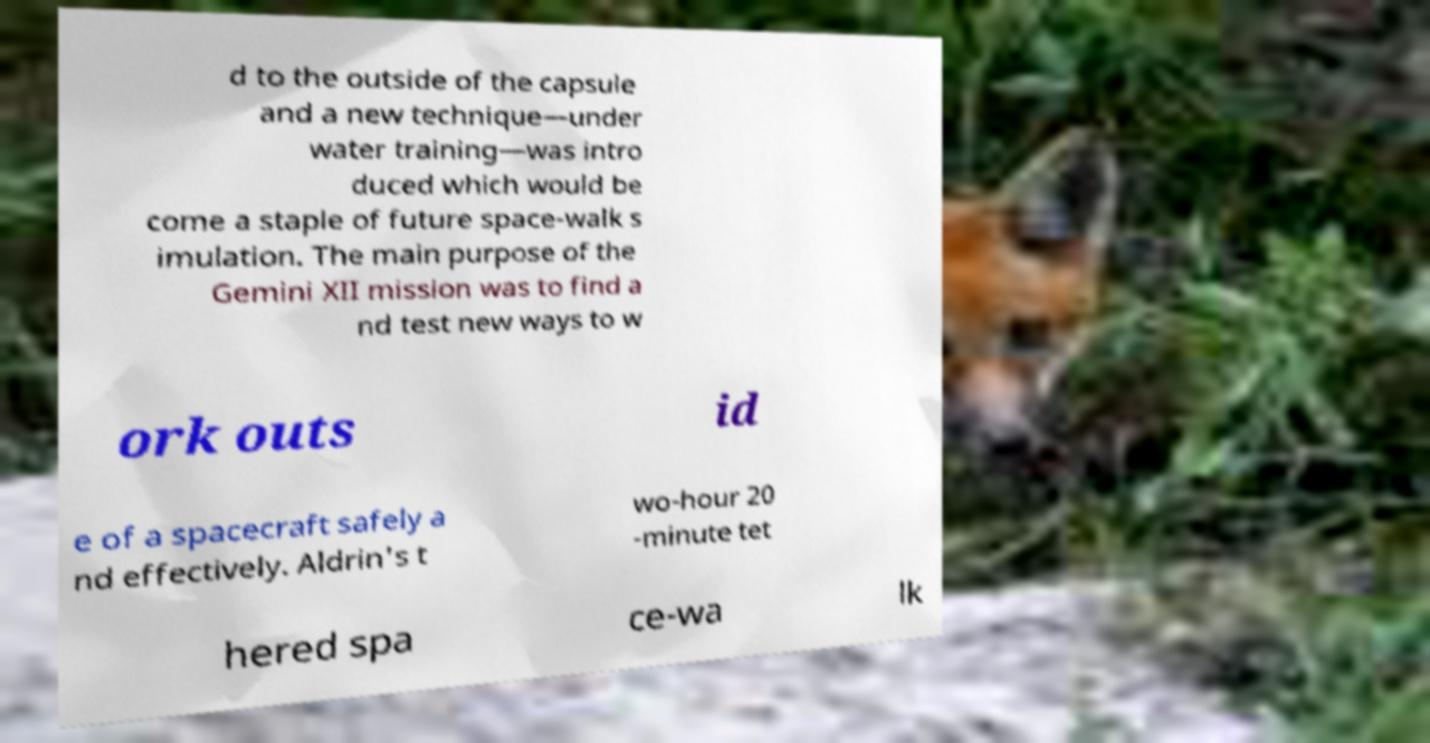Could you extract and type out the text from this image? d to the outside of the capsule and a new technique—under water training—was intro duced which would be come a staple of future space-walk s imulation. The main purpose of the Gemini XII mission was to find a nd test new ways to w ork outs id e of a spacecraft safely a nd effectively. Aldrin's t wo-hour 20 -minute tet hered spa ce-wa lk 